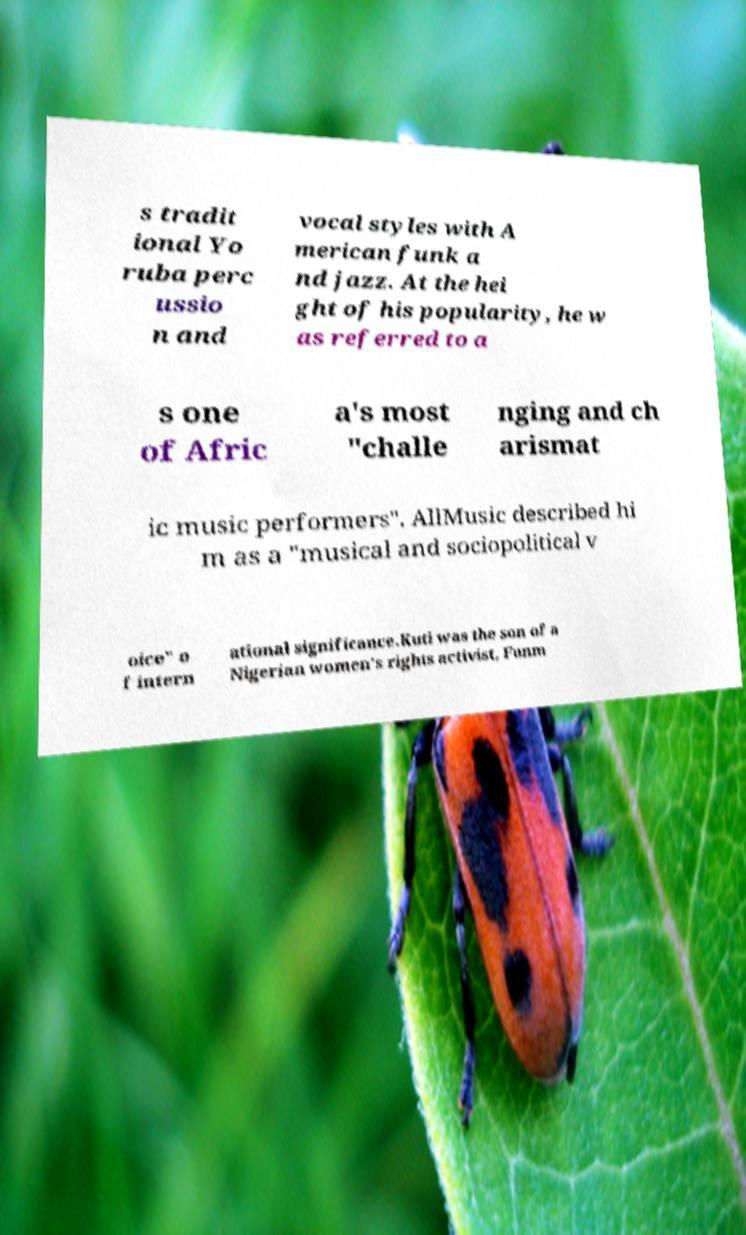Please identify and transcribe the text found in this image. s tradit ional Yo ruba perc ussio n and vocal styles with A merican funk a nd jazz. At the hei ght of his popularity, he w as referred to a s one of Afric a's most "challe nging and ch arismat ic music performers". AllMusic described hi m as a "musical and sociopolitical v oice" o f intern ational significance.Kuti was the son of a Nigerian women's rights activist, Funm 